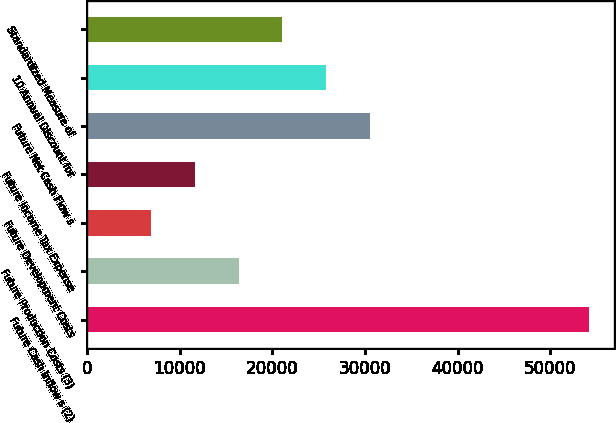Convert chart to OTSL. <chart><loc_0><loc_0><loc_500><loc_500><bar_chart><fcel>Future Cash Inflow s (2)<fcel>Future Production Costs (3)<fcel>Future Development Costs<fcel>Future Income Tax Expense<fcel>Future Net Cash Flow s<fcel>10 Annual Discount for<fcel>Standardized Measure of<nl><fcel>54184<fcel>16360.8<fcel>6905<fcel>11632.9<fcel>30544.5<fcel>25816.6<fcel>21088.7<nl></chart> 